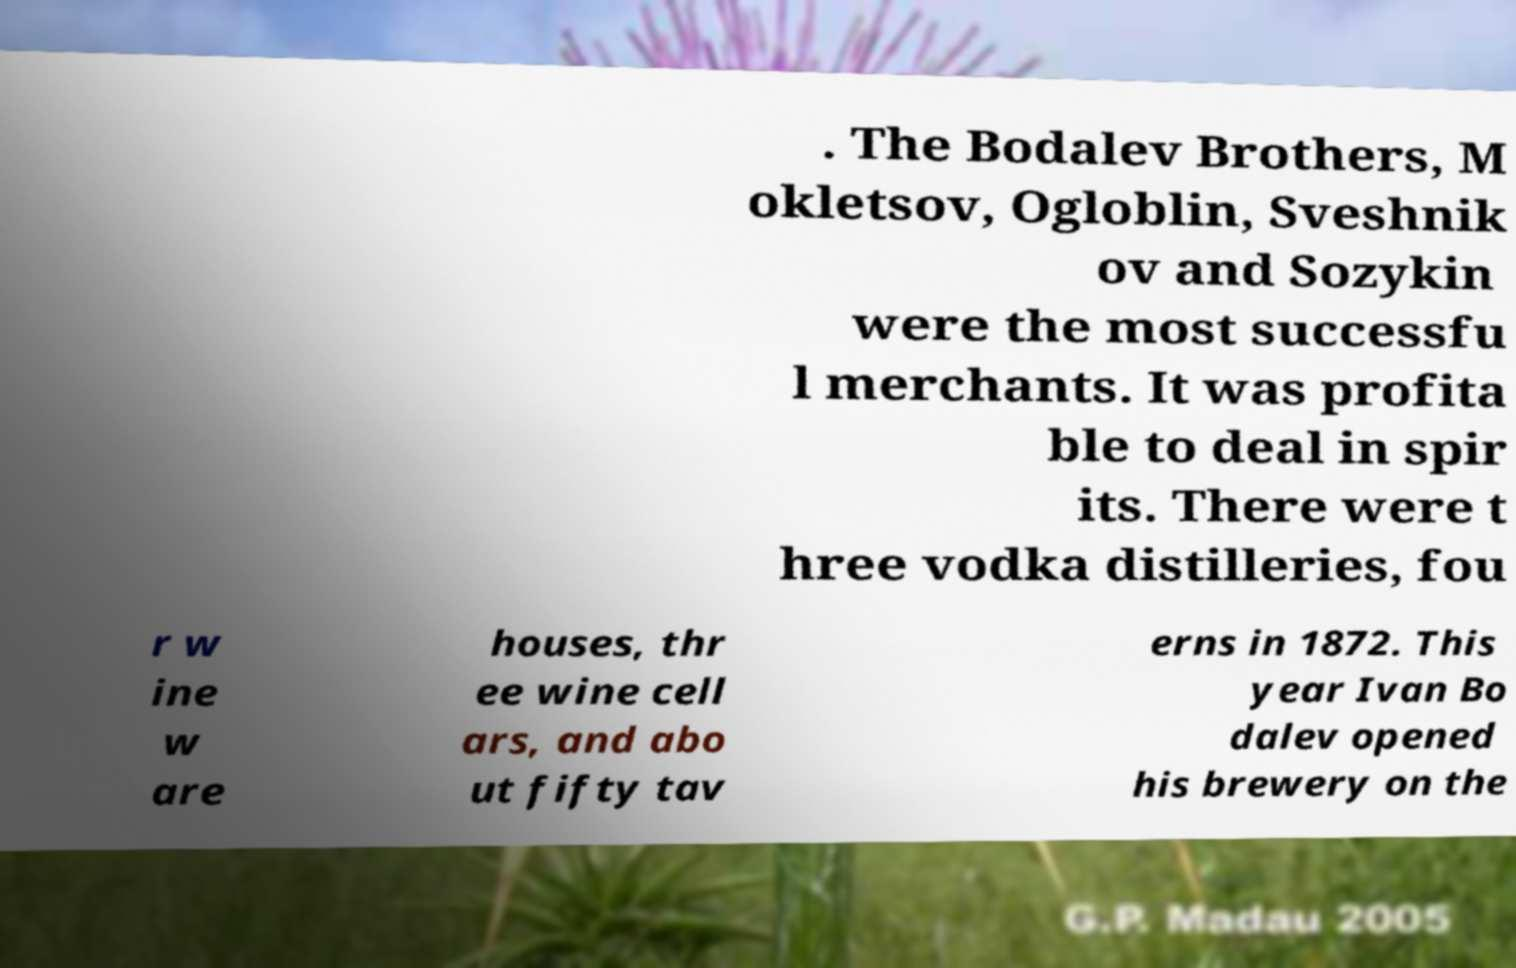For documentation purposes, I need the text within this image transcribed. Could you provide that? . The Bodalev Brothers, M okletsov, Ogloblin, Sveshnik ov and Sozykin were the most successfu l merchants. It was profita ble to deal in spir its. There were t hree vodka distilleries, fou r w ine w are houses, thr ee wine cell ars, and abo ut fifty tav erns in 1872. This year Ivan Bo dalev opened his brewery on the 